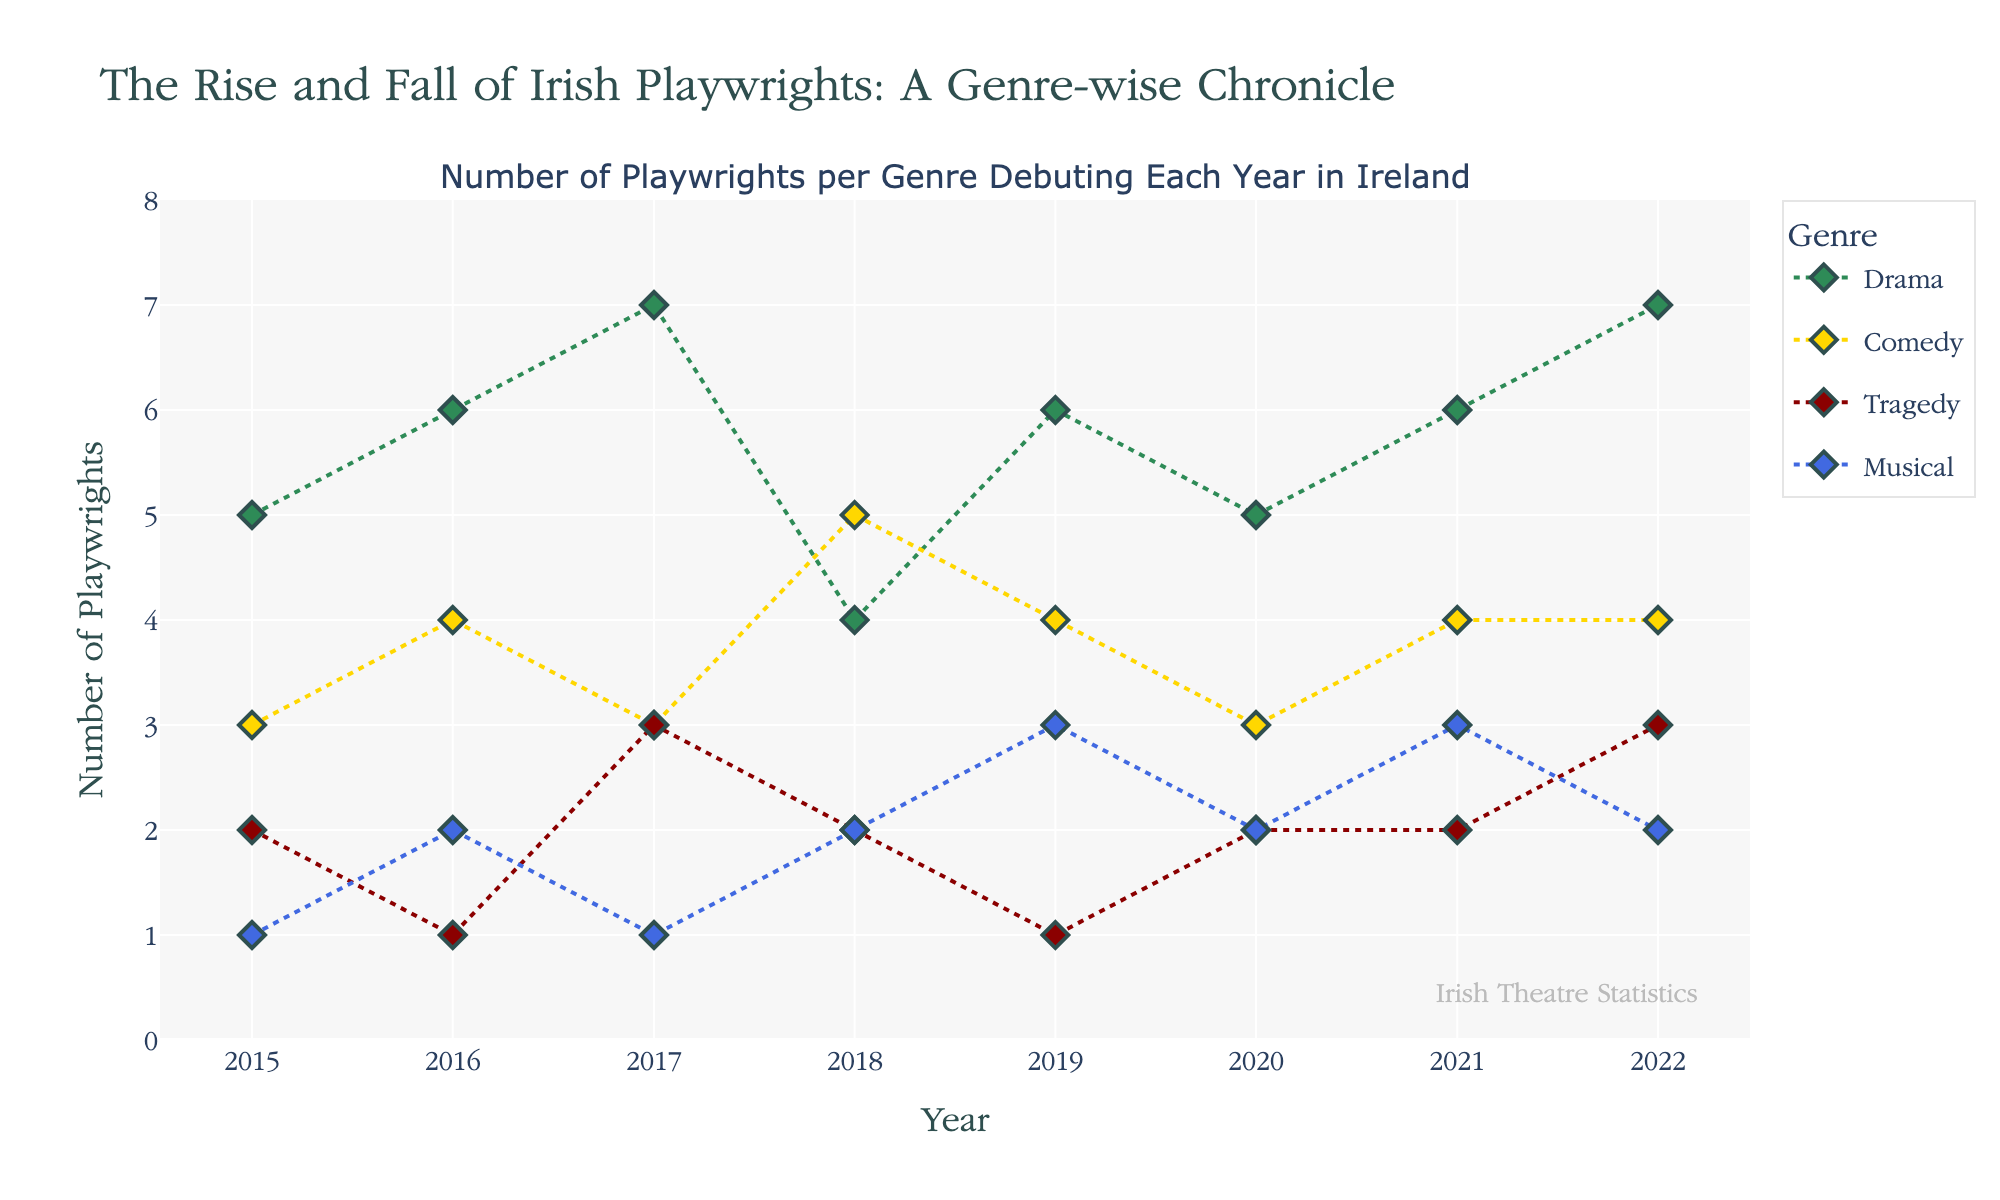What genre saw the highest number of debuting playwrights in 2022? By looking at the end of the lines on the right side of the plot for 2022, we see that the color and points on the Drama line are higher than the others in that year.
Answer: Drama Which year had the highest number of debuting playwrights for Comedy? By following the yellow line for Comedy over the years, we see that 2018 has the highest number of 5 playwrights.
Answer: 2018 Compare the number of debuting playwrights for Musical in 2015 and 2019. Which year had more? By checking the blue line for Musical at the years 2015 and 2019, we see that 2019 had 3 playwrights while 2015 had only 1.
Answer: 2019 What is the average number of debuting playwrights for Drama over the years? Summing up the values for Drama from 2015 to 2022: 5 + 6 + 7 + 4 + 6 + 5 + 6 + 7 = 46. Then divide by the number of years, which is 8. So, 46 / 8 = 5.75.
Answer: 5.75 In which year did Tragedy have the least number of debuting playwrights? By checking the red line for Tragedy, the lowest points are in 2016 and 2019, both with 1 playwright.
Answer: 2016 and 2019 Between which consecutive years did the number of debuting playwrights in Musical increase the most? By observing the blue line for Musical, the largest increase is between 2018 (2) and 2019 (3), which is an increase of 1.
Answer: 2018 and 2019 Which genre had the most stability in the number of debuting playwrights over the years? By observing the trend lines, the blue line for Musical doesn't vary as much compared to others and shows relatively small fluctuations.
Answer: Musical How did the number of debuting Drama playwrights change from 2017 to 2018? By comparing the green line for Drama at 2017 (7 playwrights) and 2018 (4 playwrights), we see a decrease by 3 playwrights.
Answer: Decreased by 3 What is the total number of debuting playwrights for all genres in 2020? Summing up the numbers across all genres for 2020: Drama (5) + Comedy (3) + Tragedy (2) + Musical (2) = 12.
Answer: 12 